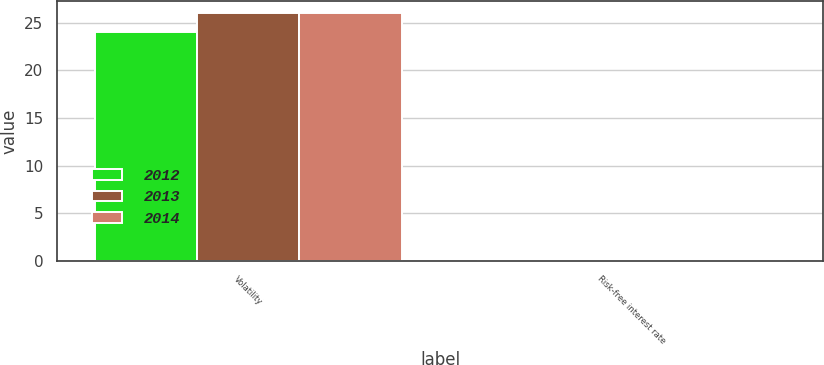Convert chart. <chart><loc_0><loc_0><loc_500><loc_500><stacked_bar_chart><ecel><fcel>Volatility<fcel>Risk-free interest rate<nl><fcel>2012<fcel>24<fcel>0.16<nl><fcel>2013<fcel>26<fcel>0.14<nl><fcel>2014<fcel>26<fcel>0.16<nl></chart> 